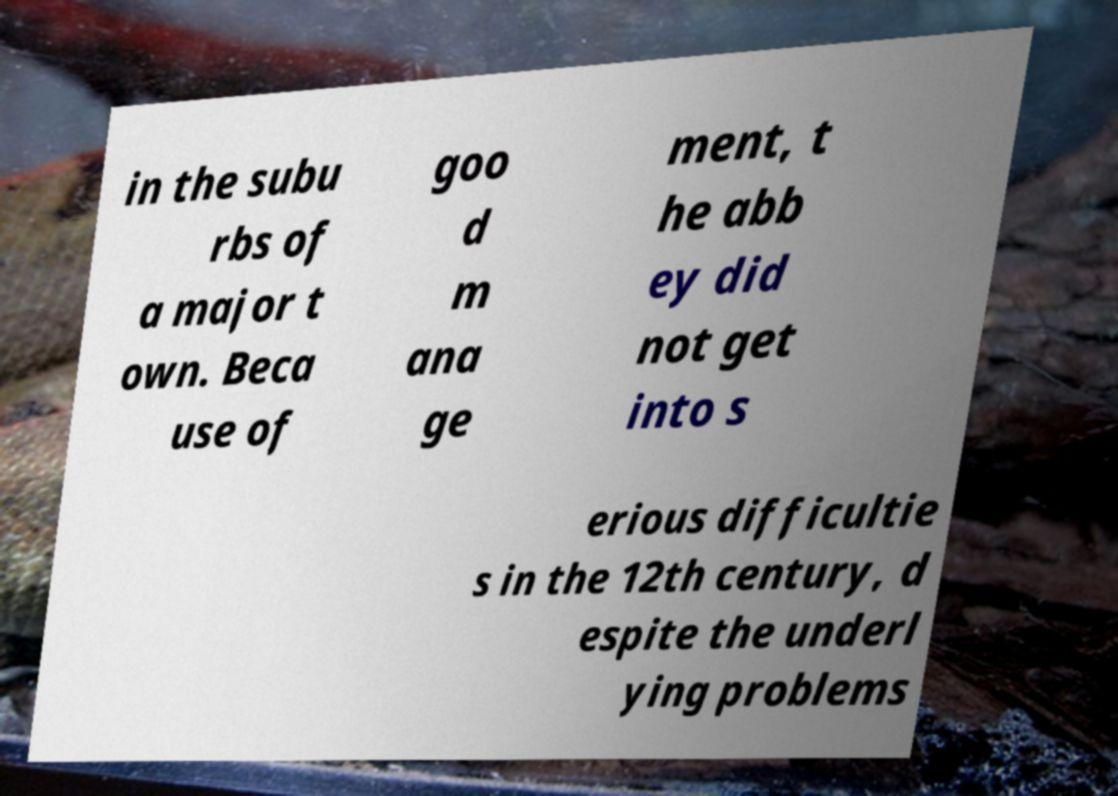Please read and relay the text visible in this image. What does it say? in the subu rbs of a major t own. Beca use of goo d m ana ge ment, t he abb ey did not get into s erious difficultie s in the 12th century, d espite the underl ying problems 